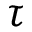Convert formula to latex. <formula><loc_0><loc_0><loc_500><loc_500>\tau</formula> 